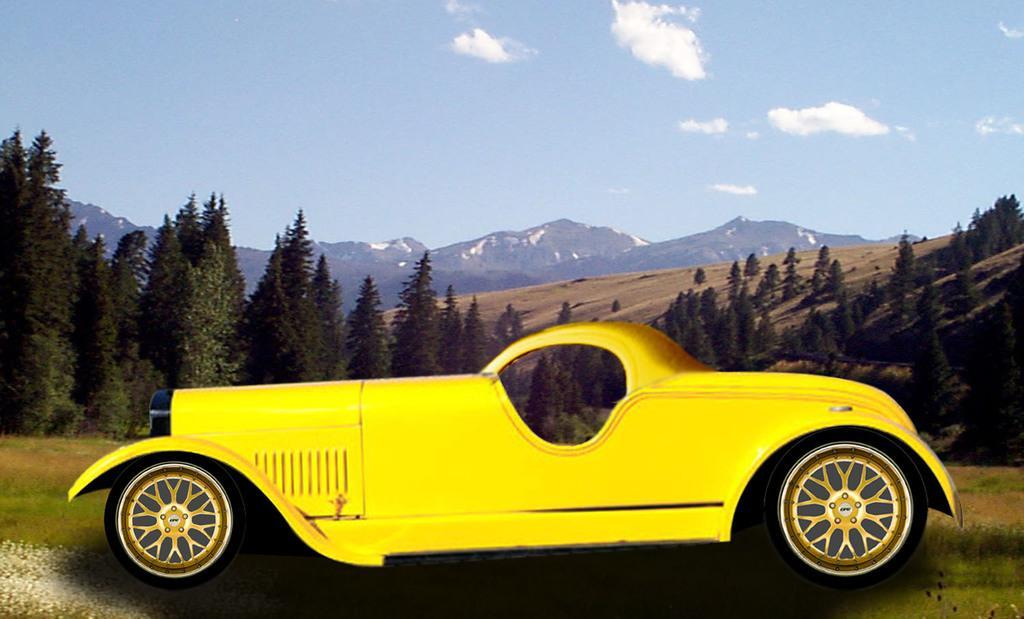Can you describe this image briefly? In this image we can see many mountains. There is a blue and a slightly cloudy sky in the image. There are many trees in the image. There is an animated car in the image. 